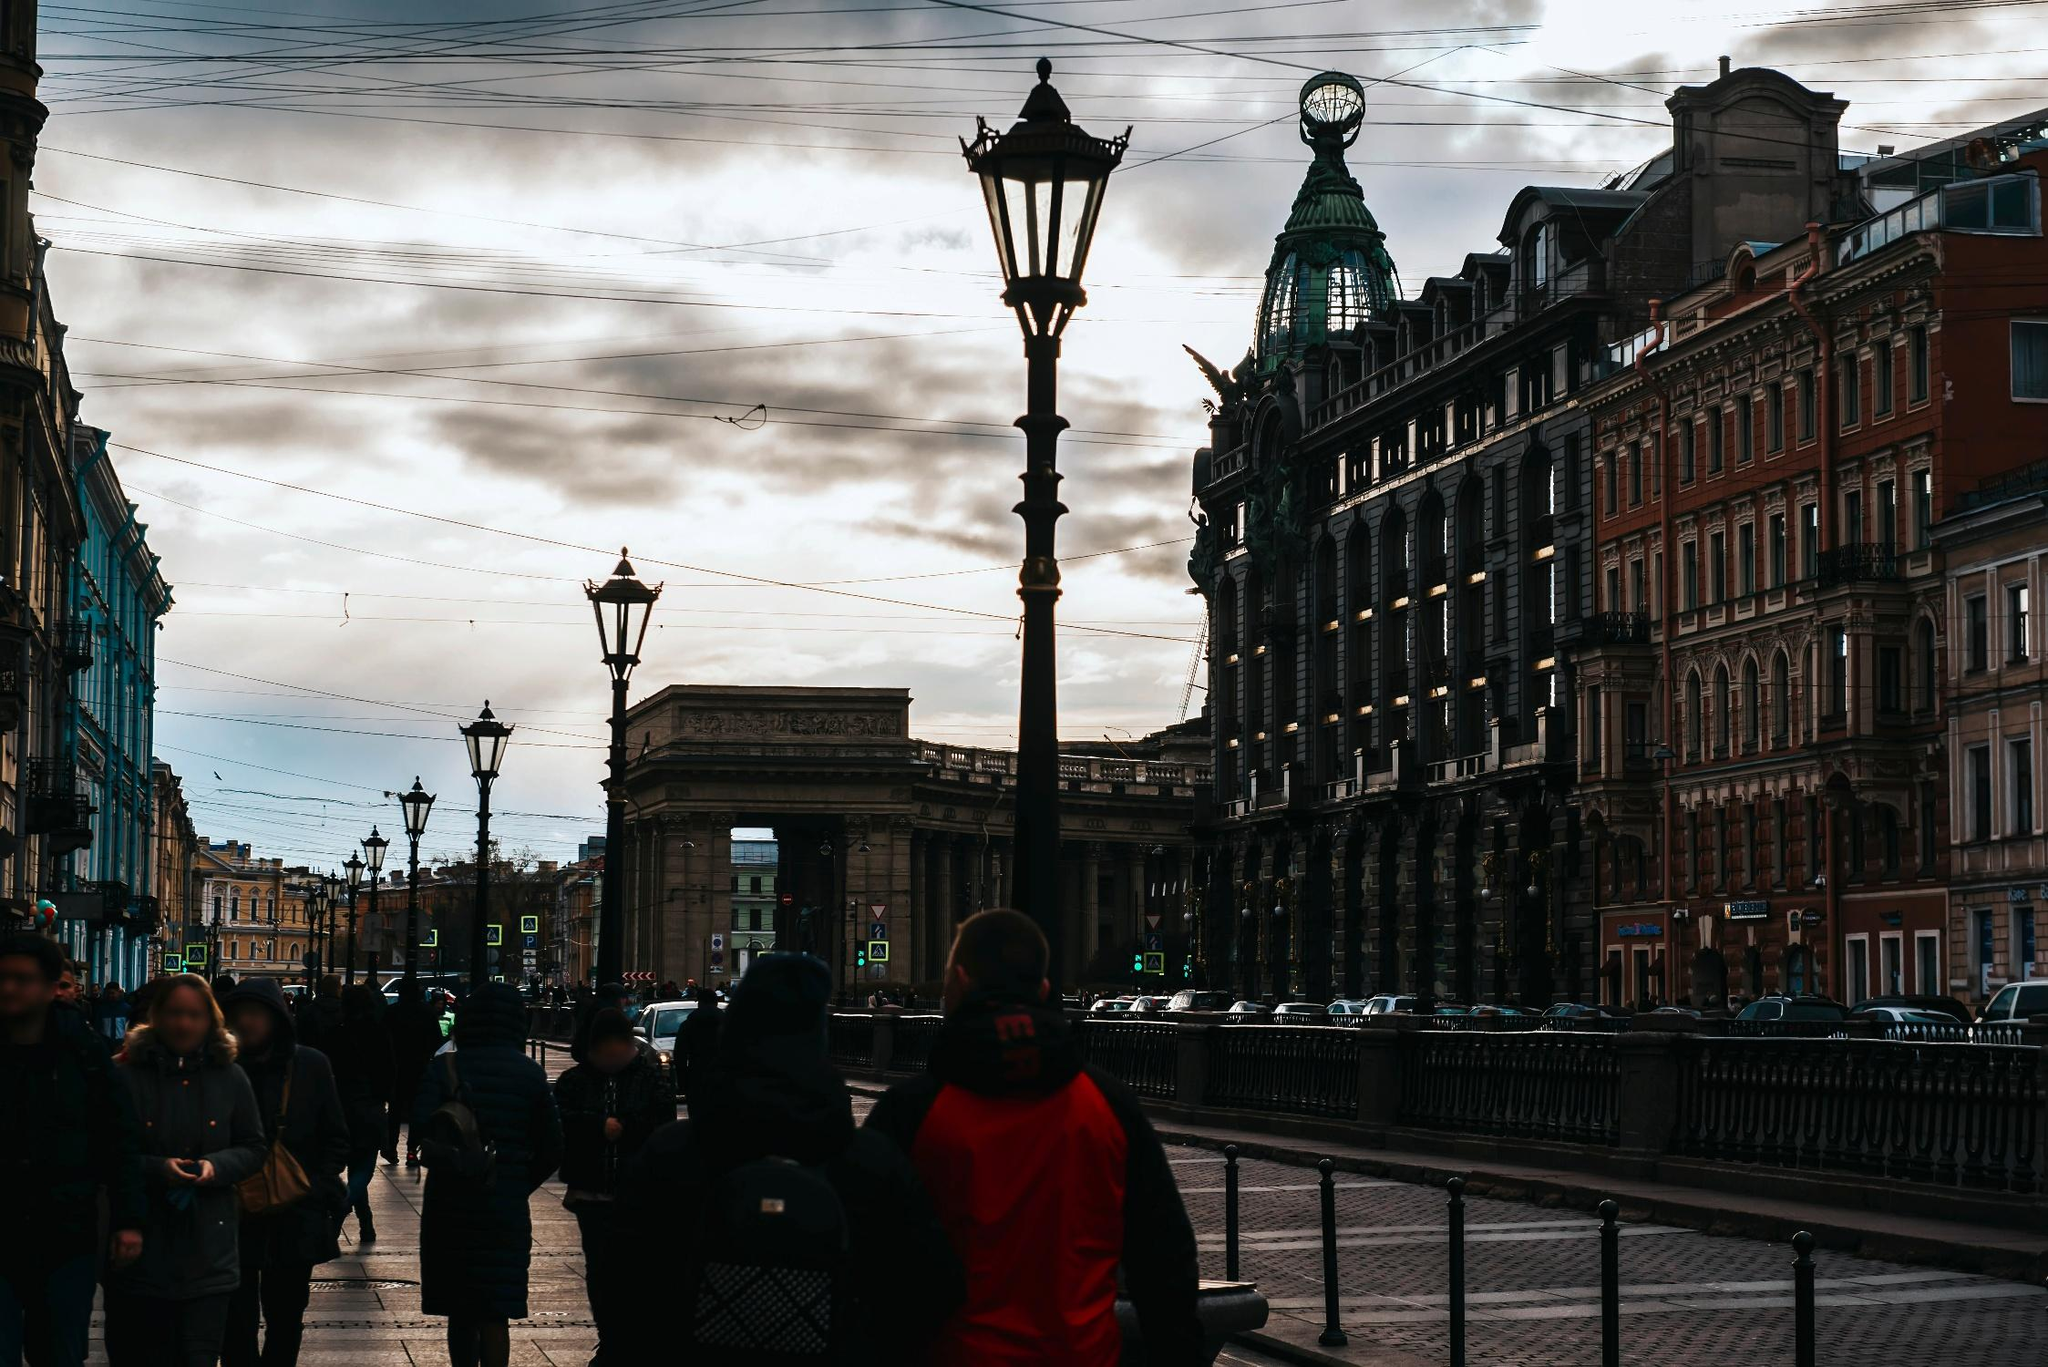What might be the significance of the large arch seen in the center of this image? The prominent arch is likely an important historical or cultural monument within the city, possibly marking a significant area or boundary. This kind of architectural structure often serves as a gateway or focal point that adds to the city's heritage. It might be commemorating a notable event or personality or could be an integral part of the city’s identity, enhancing the historic aesthetic that defines this part of the city. 